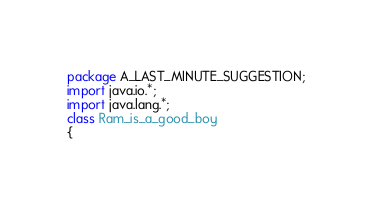Convert code to text. <code><loc_0><loc_0><loc_500><loc_500><_Java_>package A_LAST_MINUTE_SUGGESTION;
import java.io.*;
import java.lang.*;
class Ram_is_a_good_boy
{</code> 